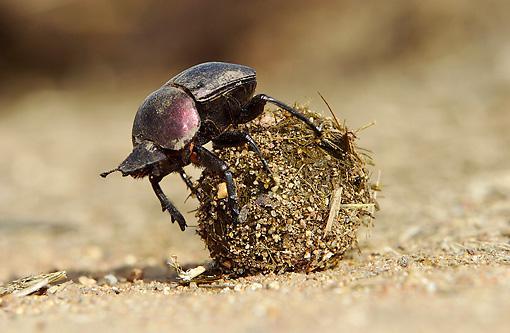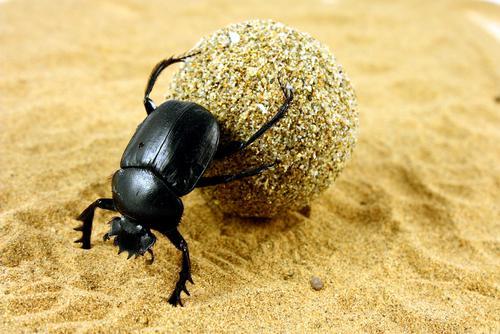The first image is the image on the left, the second image is the image on the right. Examine the images to the left and right. Is the description "The image contains two beatles" accurate? Answer yes or no. Yes. 